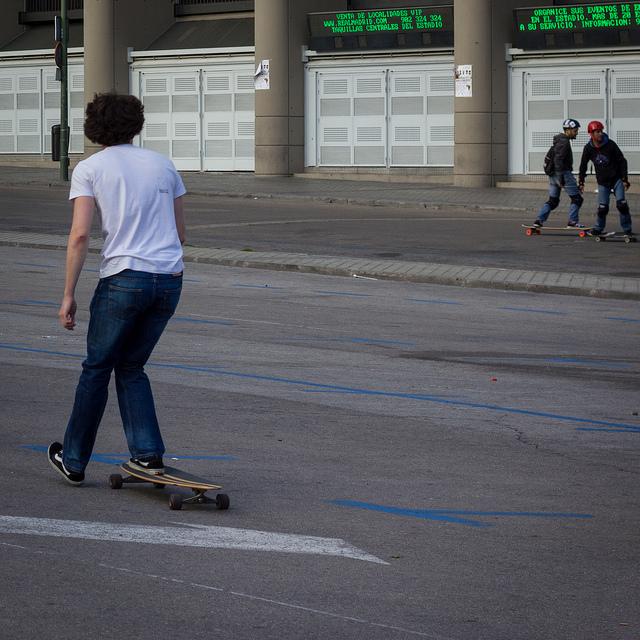Where are the arms of the front skateboarder?
Concise answer only. Down. Is that building made of drywall or brick?
Answer briefly. Brick. Why is this boy wearing a helmet?
Concise answer only. Safety. Why are people watching the skateboarder?
Keep it brief. Curious. Is the skateboarder's shirt plain or striped?
Quick response, please. Plain. How many children are in the picture?
Concise answer only. 3. Does the skateboarder have on a shirt?
Short answer required. Yes. What are the tall pillars in the background called?
Be succinct. Poles. Is the man wearing black jacket?
Write a very short answer. No. What is the man doing?
Be succinct. Skateboarding. What color are the skateboarders front wheels?
Concise answer only. Black. How many window panes are on the garage?
Concise answer only. 0. How many boards are shown?
Write a very short answer. 3. What foot is higher?
Write a very short answer. Right. How many people appear in this photo that are not the focus?
Be succinct. 2. How many skateboarders are not wearing safety equipment?
Quick response, please. 1. Does he have a hat on?
Quick response, please. No. What color are the lines?
Short answer required. Blue. Is this young man a poser?
Be succinct. No. Can you see a car in the picture?
Be succinct. No. Do you think he's trying to skateboard away from those other boys?
Concise answer only. No. What color are the skater's pants?
Quick response, please. Blue. Do the skateboard wheels glow?
Answer briefly. No. Is there any car in the photo?
Give a very brief answer. No. Who appears to be the better skateboarder?
Write a very short answer. Boy. Are they in a park?
Write a very short answer. No. How many skateboards are in this picture?
Answer briefly. 3. What color is the photo?
Give a very brief answer. Gray. Are there any birds in this photo?
Short answer required. No. Is this an older boy?
Concise answer only. Yes. How many windows are there?
Keep it brief. 0. Is the skateboarder with the white t shirt wearing anything on his head?
Concise answer only. No. How many people are in the scene?
Write a very short answer. 3. Is the boy wearing a helmet?
Keep it brief. No. What is the racial background of the kid in the foreground?
Quick response, please. White. 